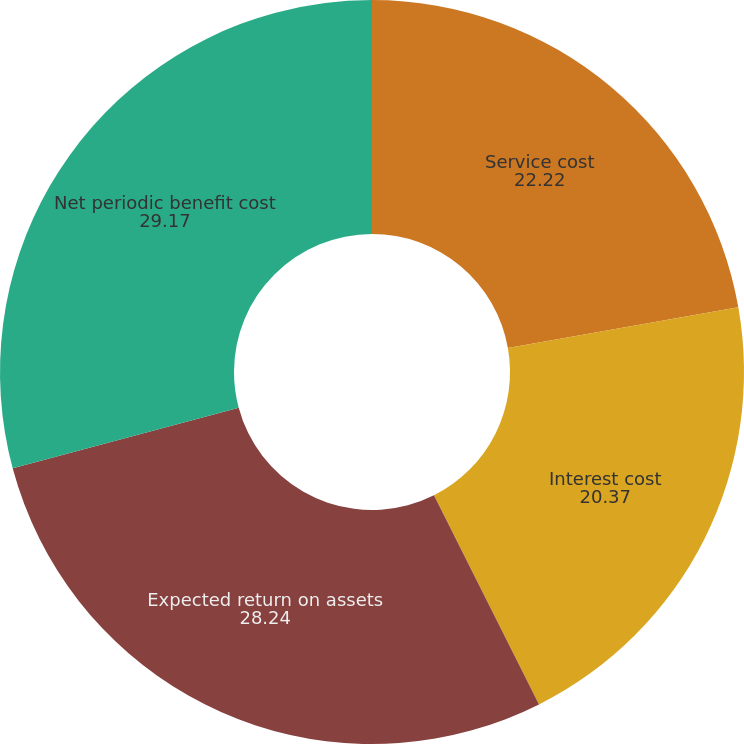Convert chart to OTSL. <chart><loc_0><loc_0><loc_500><loc_500><pie_chart><fcel>Service cost<fcel>Interest cost<fcel>Expected return on assets<fcel>Net periodic benefit cost<nl><fcel>22.22%<fcel>20.37%<fcel>28.24%<fcel>29.17%<nl></chart> 